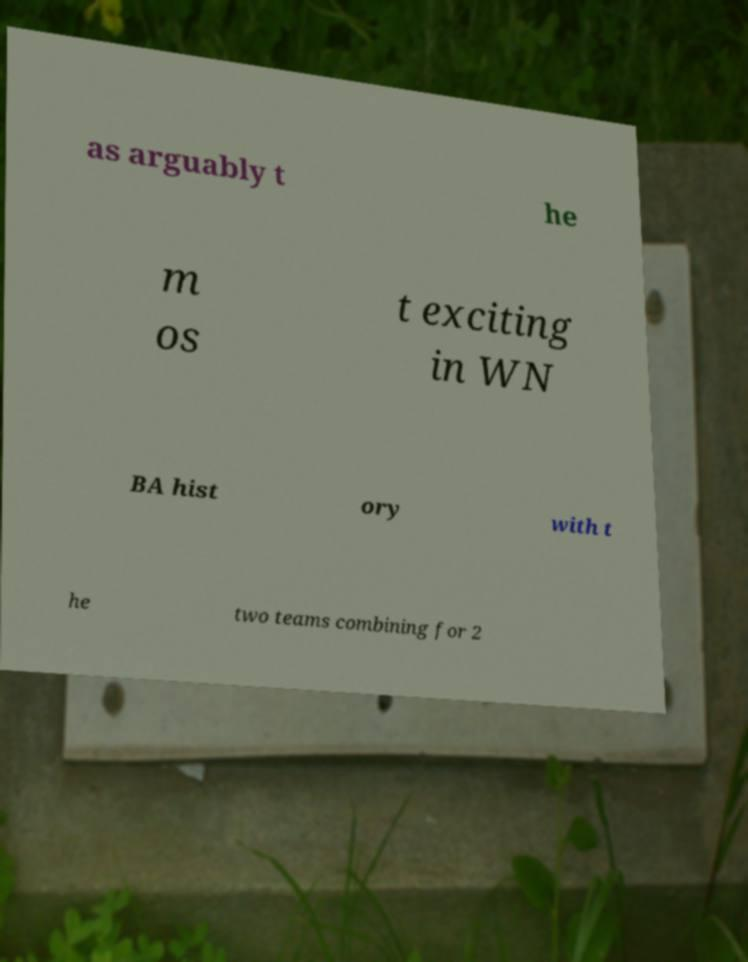Can you read and provide the text displayed in the image?This photo seems to have some interesting text. Can you extract and type it out for me? as arguably t he m os t exciting in WN BA hist ory with t he two teams combining for 2 